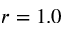Convert formula to latex. <formula><loc_0><loc_0><loc_500><loc_500>r = 1 . 0</formula> 